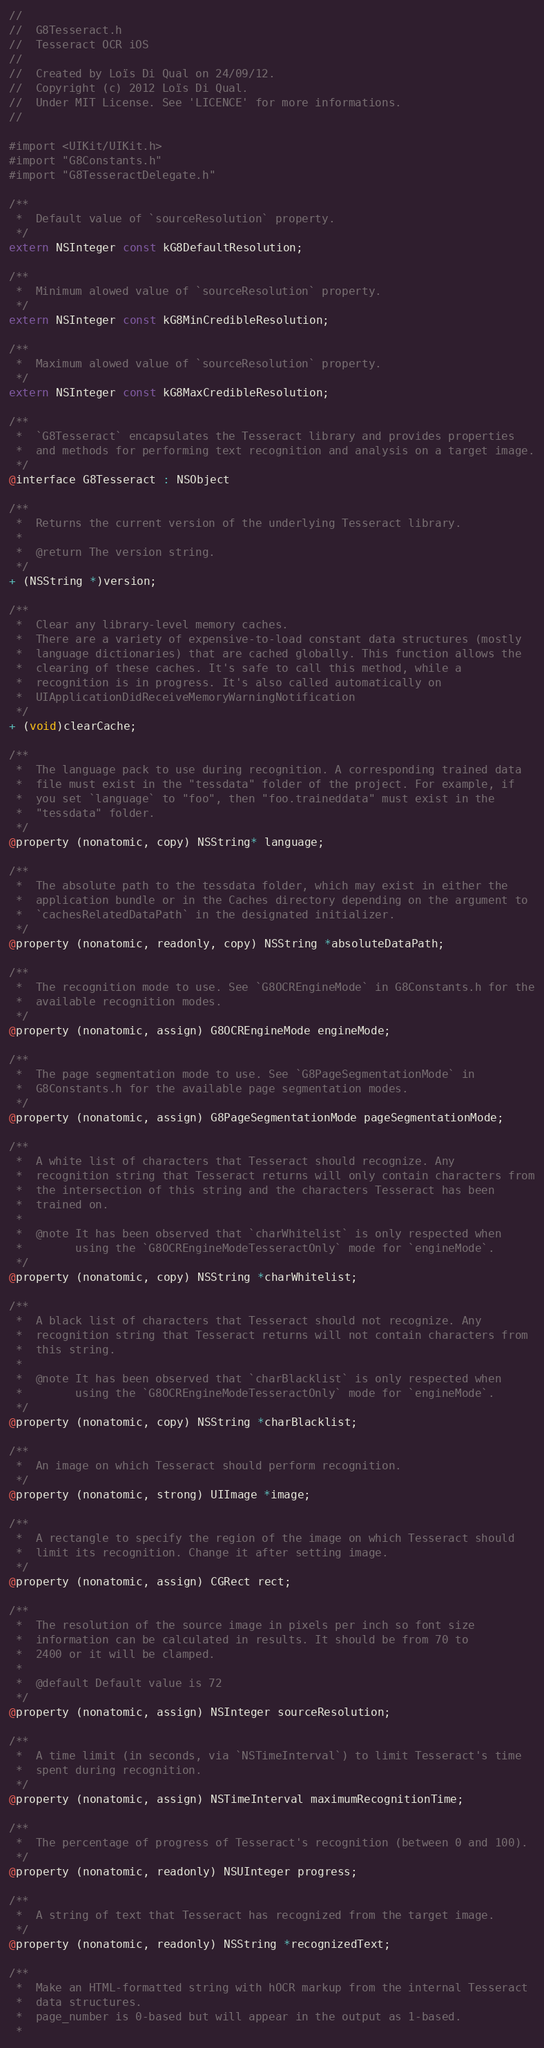<code> <loc_0><loc_0><loc_500><loc_500><_C_>//
//  G8Tesseract.h
//  Tesseract OCR iOS
//
//  Created by Loïs Di Qual on 24/09/12.
//  Copyright (c) 2012 Loïs Di Qual.
//  Under MIT License. See 'LICENCE' for more informations.
//

#import <UIKit/UIKit.h>
#import "G8Constants.h"
#import "G8TesseractDelegate.h"

/**
 *  Default value of `sourceResolution` property.
 */
extern NSInteger const kG8DefaultResolution;

/**
 *  Minimum alowed value of `sourceResolution` property.
 */
extern NSInteger const kG8MinCredibleResolution;

/**
 *  Maximum alowed value of `sourceResolution` property.
 */
extern NSInteger const kG8MaxCredibleResolution;

/**
 *  `G8Tesseract` encapsulates the Tesseract library and provides properties
 *  and methods for performing text recognition and analysis on a target image.
 */
@interface G8Tesseract : NSObject

/**
 *  Returns the current version of the underlying Tesseract library.
 *
 *  @return The version string.
 */
+ (NSString *)version;

/**
 *  Clear any library-level memory caches.
 *  There are a variety of expensive-to-load constant data structures (mostly
 *  language dictionaries) that are cached globally. This function allows the
 *  clearing of these caches. It's safe to call this method, while a 
 *  recognition is in progress. It's also called automatically on 
 *  UIApplicationDidReceiveMemoryWarningNotification
 */
+ (void)clearCache;

/**
 *  The language pack to use during recognition. A corresponding trained data
 *  file must exist in the "tessdata" folder of the project. For example, if
 *  you set `language` to "foo", then "foo.traineddata" must exist in the
 *  "tessdata" folder.
 */
@property (nonatomic, copy) NSString* language;

/**
 *  The absolute path to the tessdata folder, which may exist in either the
 *  application bundle or in the Caches directory depending on the argument to
 *  `cachesRelatedDataPath` in the designated initializer.
 */
@property (nonatomic, readonly, copy) NSString *absoluteDataPath;

/**
 *  The recognition mode to use. See `G8OCREngineMode` in G8Constants.h for the
 *  available recognition modes.
 */
@property (nonatomic, assign) G8OCREngineMode engineMode;

/**
 *  The page segmentation mode to use. See `G8PageSegmentationMode` in
 *  G8Constants.h for the available page segmentation modes.
 */
@property (nonatomic, assign) G8PageSegmentationMode pageSegmentationMode;

/**
 *  A white list of characters that Tesseract should recognize. Any
 *  recognition string that Tesseract returns will only contain characters from
 *  the intersection of this string and the characters Tesseract has been
 *  trained on.
 *
 *  @note It has been observed that `charWhitelist` is only respected when
 *        using the `G8OCREngineModeTesseractOnly` mode for `engineMode`.
 */
@property (nonatomic, copy) NSString *charWhitelist;

/**
 *  A black list of characters that Tesseract should not recognize. Any
 *  recognition string that Tesseract returns will not contain characters from
 *  this string.
 *
 *  @note It has been observed that `charBlacklist` is only respected when
 *        using the `G8OCREngineModeTesseractOnly` mode for `engineMode`.
 */
@property (nonatomic, copy) NSString *charBlacklist;

/**
 *  An image on which Tesseract should perform recognition.
 */
@property (nonatomic, strong) UIImage *image;

/**
 *  A rectangle to specify the region of the image on which Tesseract should
 *  limit its recognition. Change it after setting image.
 */
@property (nonatomic, assign) CGRect rect;

/**
 *  The resolution of the source image in pixels per inch so font size
 *  information can be calculated in results. It should be from 70 to
 *  2400 or it will be clamped.
 *
 *  @default Default value is 72
 */
@property (nonatomic, assign) NSInteger sourceResolution;

/**
 *  A time limit (in seconds, via `NSTimeInterval`) to limit Tesseract's time
 *  spent during recognition.
 */
@property (nonatomic, assign) NSTimeInterval maximumRecognitionTime;

/**
 *  The percentage of progress of Tesseract's recognition (between 0 and 100).
 */
@property (nonatomic, readonly) NSUInteger progress;

/**
 *  A string of text that Tesseract has recognized from the target image.
 */
@property (nonatomic, readonly) NSString *recognizedText;

/**
 *  Make an HTML-formatted string with hOCR markup from the internal Tesseract
 *  data structures.
 *  page_number is 0-based but will appear in the output as 1-based.
 *</code> 